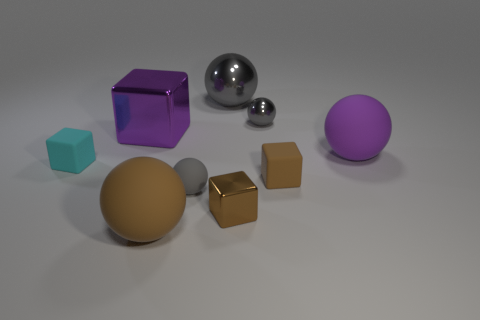There is a tiny rubber object that is the same color as the tiny metal cube; what is its shape?
Your answer should be compact. Cube. How many blocks are either brown metallic things or small brown objects?
Provide a short and direct response. 2. What number of tiny gray matte spheres are behind the big purple object that is on the left side of the matte sphere behind the gray matte thing?
Make the answer very short. 0. What is the color of the matte sphere that is the same size as the cyan cube?
Offer a very short reply. Gray. How many other things are the same color as the big shiny block?
Make the answer very short. 1. Is the number of small cyan rubber objects that are right of the purple metal block greater than the number of big purple matte spheres?
Offer a terse response. No. Is the purple cube made of the same material as the large purple sphere?
Give a very brief answer. No. How many objects are small gray objects that are in front of the cyan object or metal objects?
Offer a terse response. 5. How many other objects are the same size as the brown metallic thing?
Your response must be concise. 4. Is the number of metal balls on the right side of the tiny gray metallic sphere the same as the number of gray spheres in front of the brown sphere?
Ensure brevity in your answer.  Yes. 